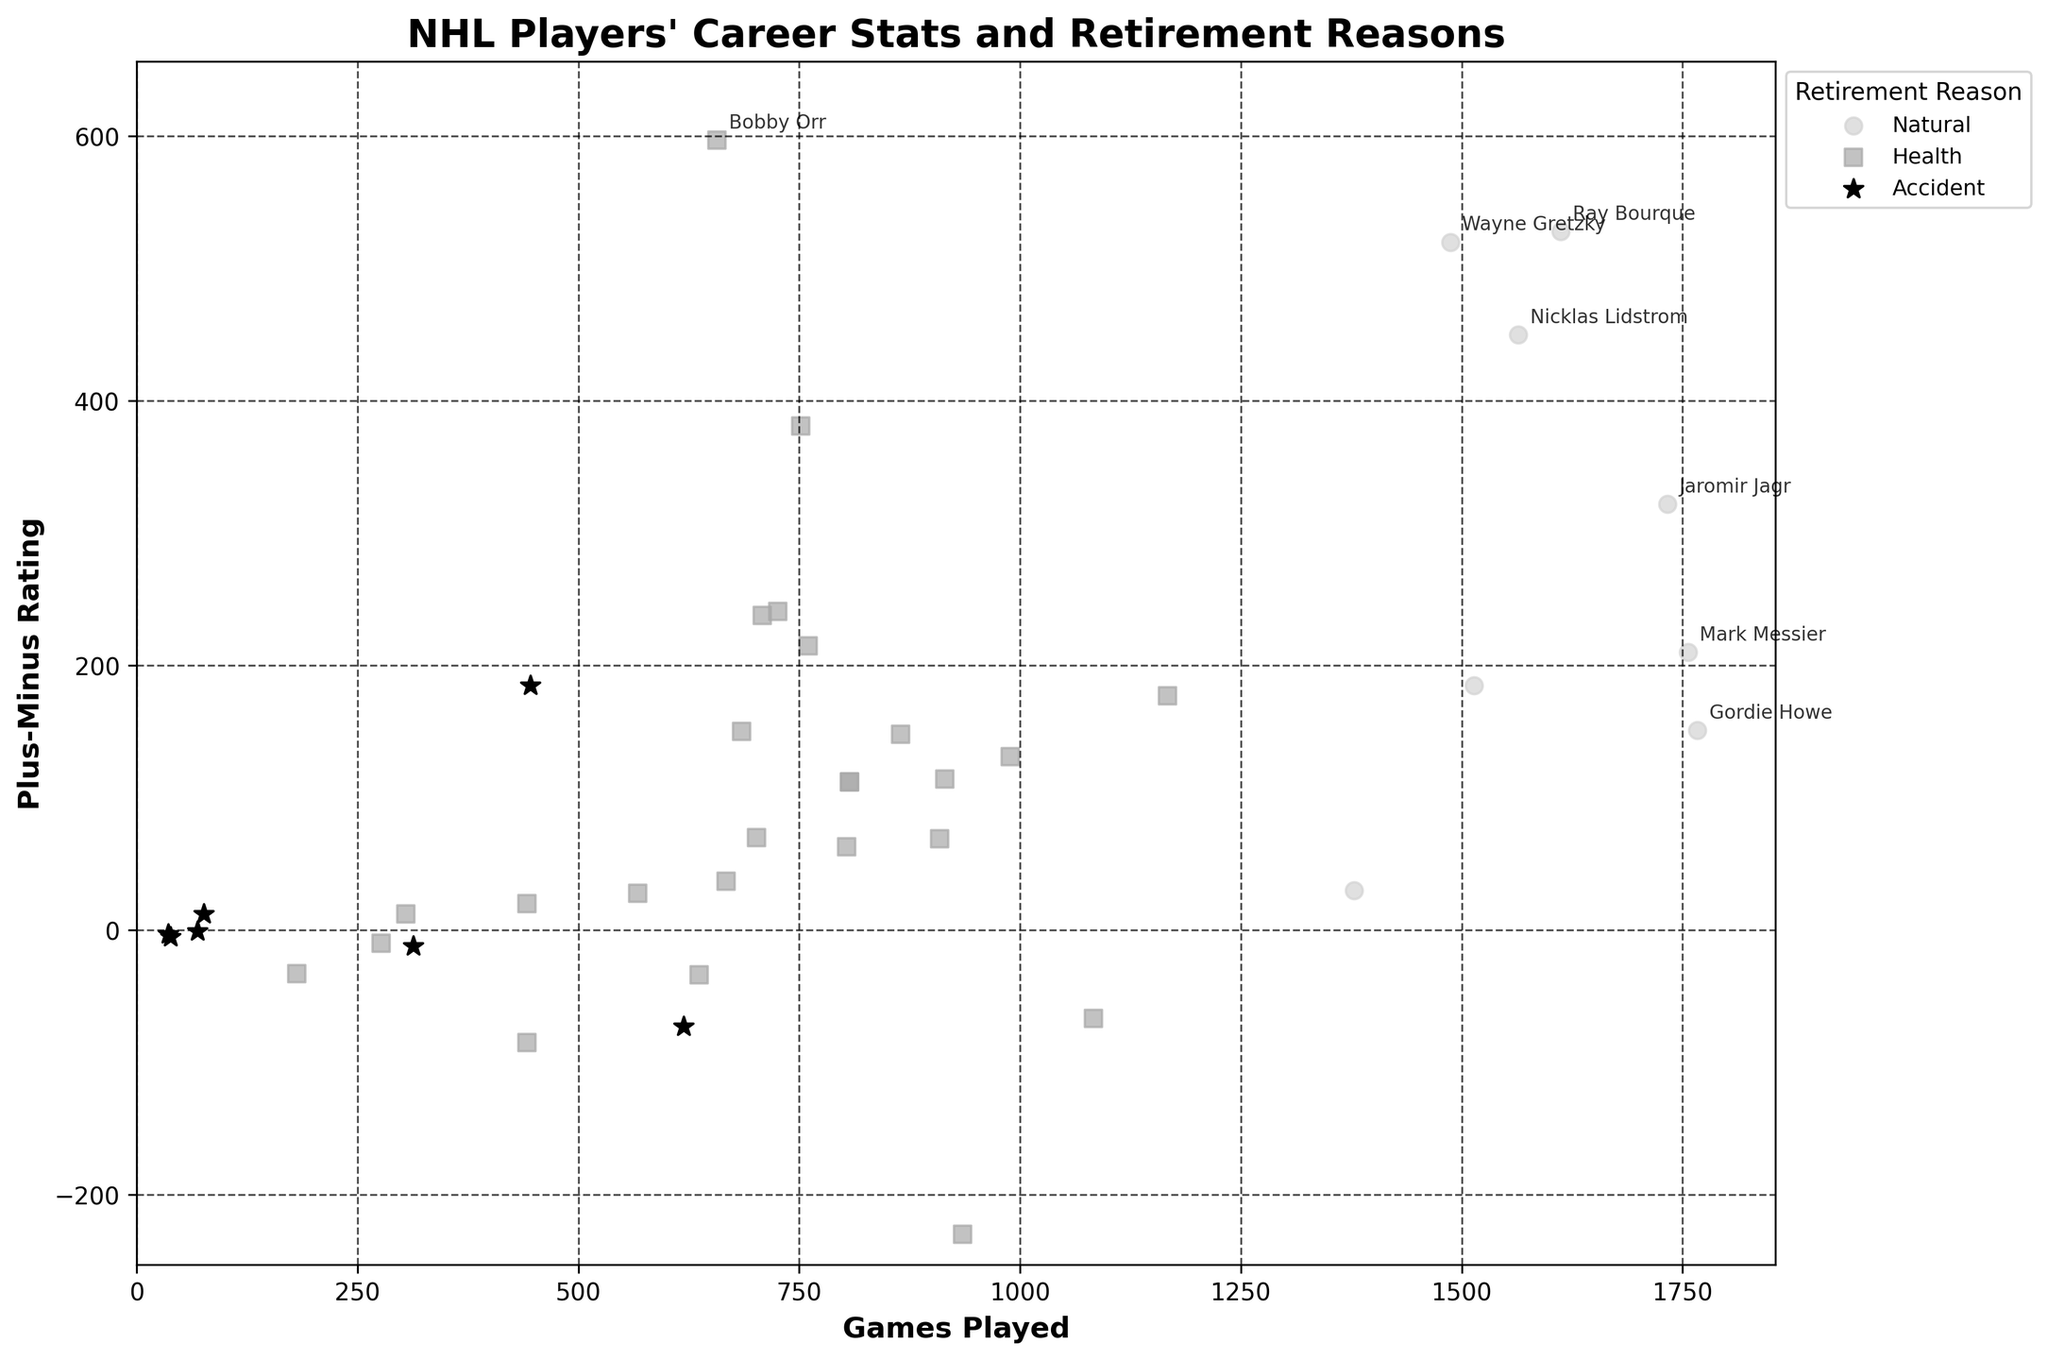What's the highest plus-minus rating achieved by a player who retired naturally? To find the highest plus-minus rating among naturally retired players, look for markers with the lightest shade and check their plus-minus values. The highest is Wayne Gretzky with 520.
Answer: 520 Who has played the most games among players who retired due to health concerns? Find the marker with a square shape (represents health concerns) that is furthest to the right along the x-axis (Games Played). Chris Pronger, with 1167 games, is the farthest.
Answer: Chris Pronger How many players with a plus-minus rating above 50 retired due to accidents? Identify the black star markers with a plus-minus rating greater than 50 on the y-axis. Only Vladimir Konstantinov, with a rating of 185, fits this criterion.
Answer: 1 What's the average plus-minus rating of players who played more than 1000 games and retired naturally? Select naturally retired players (light gray markers) who played over 1000 games, then calculate the average of their plus-minus ratings: Wayne Gretzky (520), Mark Messier (210), Steve Yzerman (185), Jaromir Jagr (322), Ray Bourque (528), Nicklas Lidstrom (450). Average is (520+210+185+322+528+450)/6 = 368.
Answer: 368 Which group of players (Natural, Health, or Accident) tends to have a higher plus-minus rating on average? Visually estimate the overall position of each group on the y-axis. Natural markers (light gray) are generally higher than health (dark gray) and accident (black) markers.
Answer: Natural Is there a player who retired due to an accident and has a minus plus-minus rating? Identify black star markers on the plot that lie below the zero line on the y-axis. There are a few: Bryan Berard (-73), Ace Bailey (-12), Bill Masterton (-5), Luc Bourdon (-3), Derek Boogaard (-10).
Answer: Yes Compare the average games played by players who retired naturally to those who retired due to health concerns. Who had the higher average? Calculate the average games played for natural retirements: (1487+1767+1756+1514+1733+1378+1612+1564)/8 = 1601. For health retirements: sum of the games played by health retirees / number of health retirees, which tends to be lower as most health-related retirements involve fewer games.
Answer: Natural Which player has the lowest plus-minus rating among those who retired due to health concerns? Among the square markers (health) on the plot, find the one with the lowest position on the y-axis. Bob Probert, with -230, is the lowest.
Answer: Bob Probert 